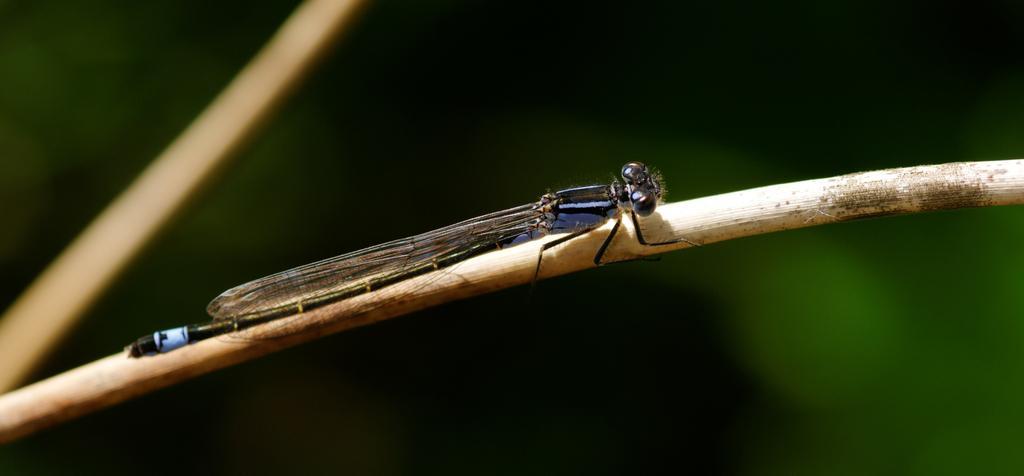How would you summarize this image in a sentence or two? In this image in the front there is an insect and the background is blurry. 